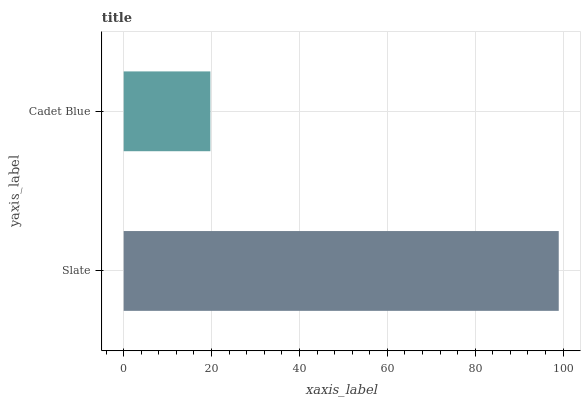Is Cadet Blue the minimum?
Answer yes or no. Yes. Is Slate the maximum?
Answer yes or no. Yes. Is Cadet Blue the maximum?
Answer yes or no. No. Is Slate greater than Cadet Blue?
Answer yes or no. Yes. Is Cadet Blue less than Slate?
Answer yes or no. Yes. Is Cadet Blue greater than Slate?
Answer yes or no. No. Is Slate less than Cadet Blue?
Answer yes or no. No. Is Slate the high median?
Answer yes or no. Yes. Is Cadet Blue the low median?
Answer yes or no. Yes. Is Cadet Blue the high median?
Answer yes or no. No. Is Slate the low median?
Answer yes or no. No. 